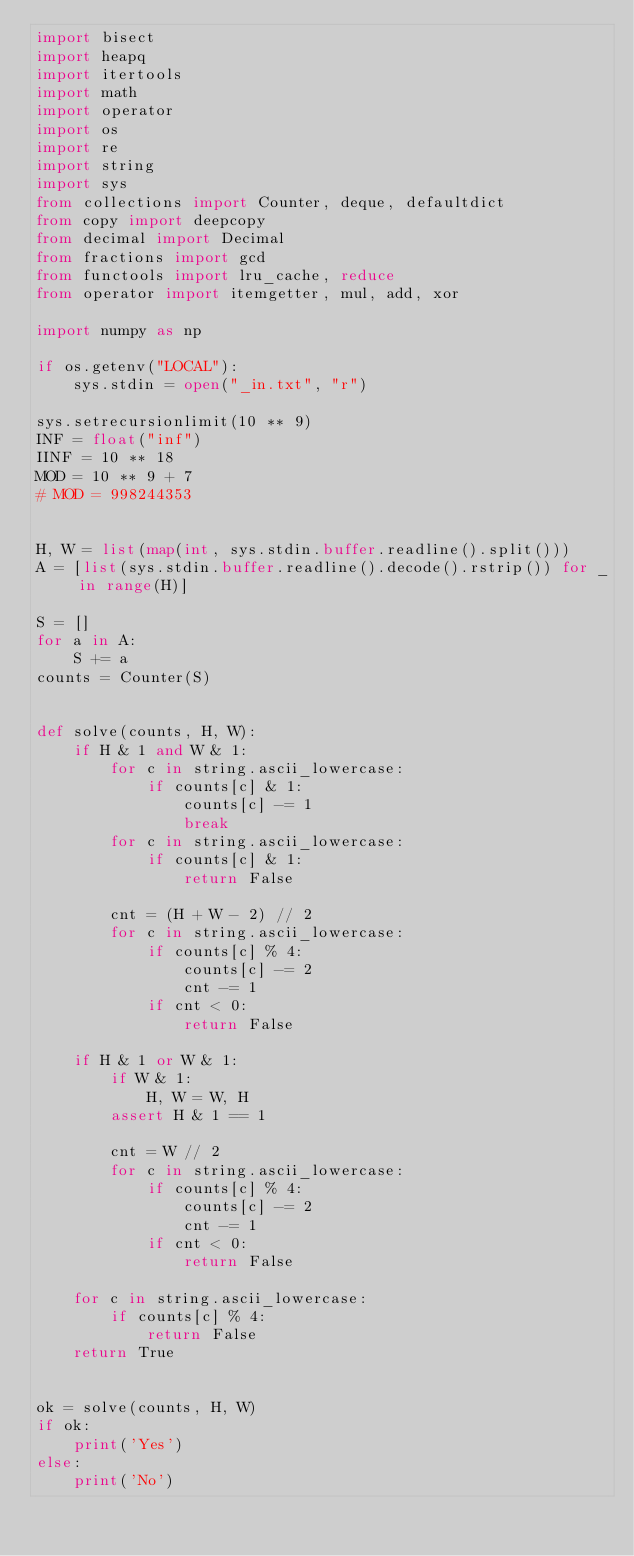<code> <loc_0><loc_0><loc_500><loc_500><_Python_>import bisect
import heapq
import itertools
import math
import operator
import os
import re
import string
import sys
from collections import Counter, deque, defaultdict
from copy import deepcopy
from decimal import Decimal
from fractions import gcd
from functools import lru_cache, reduce
from operator import itemgetter, mul, add, xor

import numpy as np

if os.getenv("LOCAL"):
    sys.stdin = open("_in.txt", "r")

sys.setrecursionlimit(10 ** 9)
INF = float("inf")
IINF = 10 ** 18
MOD = 10 ** 9 + 7
# MOD = 998244353


H, W = list(map(int, sys.stdin.buffer.readline().split()))
A = [list(sys.stdin.buffer.readline().decode().rstrip()) for _ in range(H)]

S = []
for a in A:
    S += a
counts = Counter(S)


def solve(counts, H, W):
    if H & 1 and W & 1:
        for c in string.ascii_lowercase:
            if counts[c] & 1:
                counts[c] -= 1
                break
        for c in string.ascii_lowercase:
            if counts[c] & 1:
                return False

        cnt = (H + W - 2) // 2
        for c in string.ascii_lowercase:
            if counts[c] % 4:
                counts[c] -= 2
                cnt -= 1
            if cnt < 0:
                return False

    if H & 1 or W & 1:
        if W & 1:
            H, W = W, H
        assert H & 1 == 1

        cnt = W // 2
        for c in string.ascii_lowercase:
            if counts[c] % 4:
                counts[c] -= 2
                cnt -= 1
            if cnt < 0:
                return False

    for c in string.ascii_lowercase:
        if counts[c] % 4:
            return False
    return True


ok = solve(counts, H, W)
if ok:
    print('Yes')
else:
    print('No')

</code> 